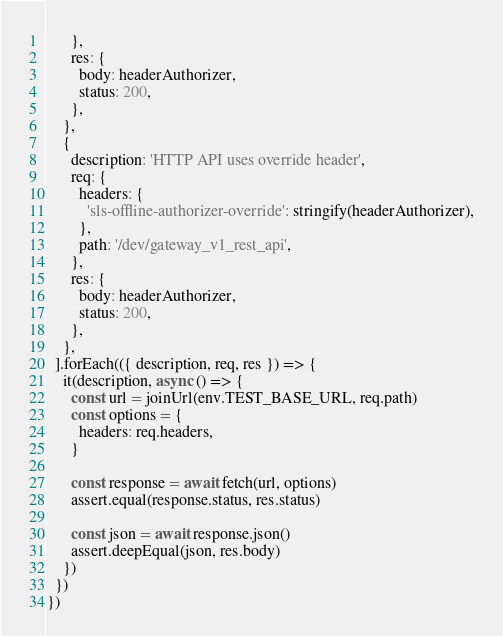Convert code to text. <code><loc_0><loc_0><loc_500><loc_500><_JavaScript_>      },
      res: {
        body: headerAuthorizer,
        status: 200,
      },
    },
    {
      description: 'HTTP API uses override header',
      req: {
        headers: {
          'sls-offline-authorizer-override': stringify(headerAuthorizer),
        },
        path: '/dev/gateway_v1_rest_api',
      },
      res: {
        body: headerAuthorizer,
        status: 200,
      },
    },
  ].forEach(({ description, req, res }) => {
    it(description, async () => {
      const url = joinUrl(env.TEST_BASE_URL, req.path)
      const options = {
        headers: req.headers,
      }

      const response = await fetch(url, options)
      assert.equal(response.status, res.status)

      const json = await response.json()
      assert.deepEqual(json, res.body)
    })
  })
})
</code> 